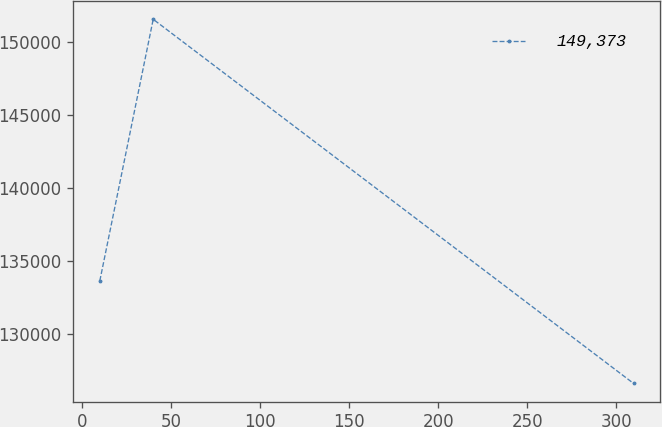Convert chart to OTSL. <chart><loc_0><loc_0><loc_500><loc_500><line_chart><ecel><fcel>149,373<nl><fcel>9.77<fcel>133665<nl><fcel>39.76<fcel>151576<nl><fcel>309.69<fcel>126638<nl></chart> 